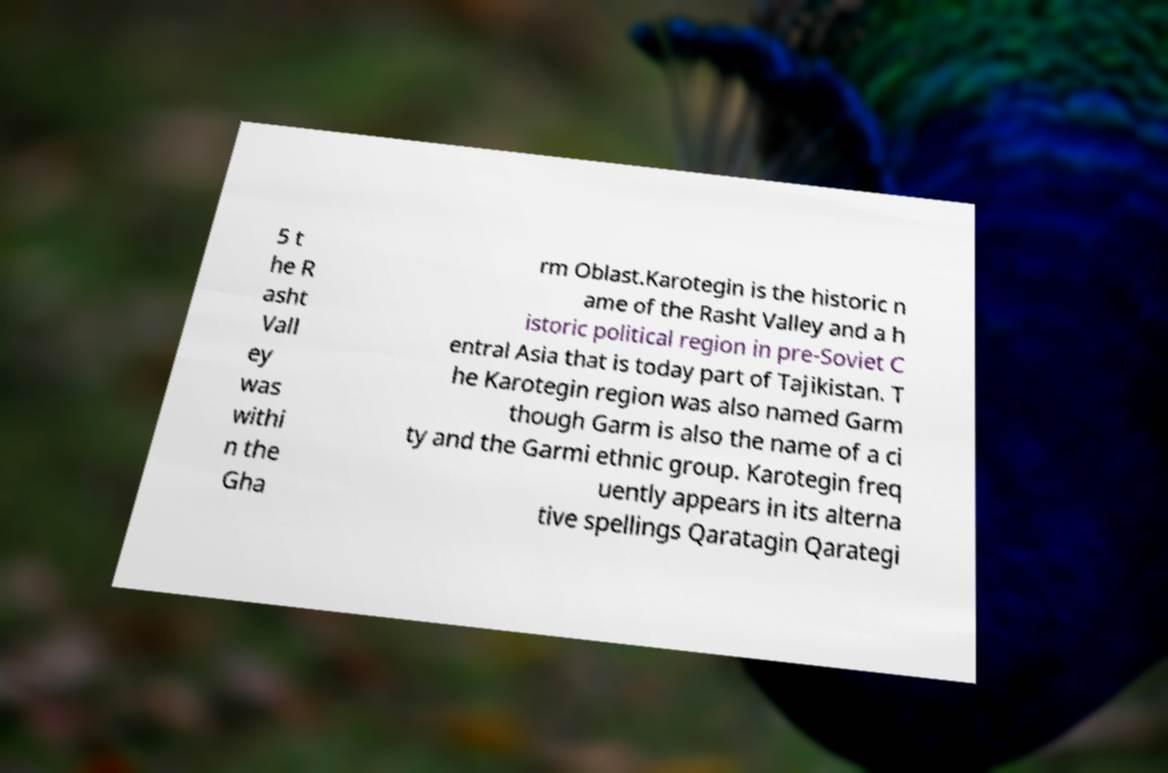For documentation purposes, I need the text within this image transcribed. Could you provide that? 5 t he R asht Vall ey was withi n the Gha rm Oblast.Karotegin is the historic n ame of the Rasht Valley and a h istoric political region in pre-Soviet C entral Asia that is today part of Tajikistan. T he Karotegin region was also named Garm though Garm is also the name of a ci ty and the Garmi ethnic group. Karotegin freq uently appears in its alterna tive spellings Qaratagin Qarategi 